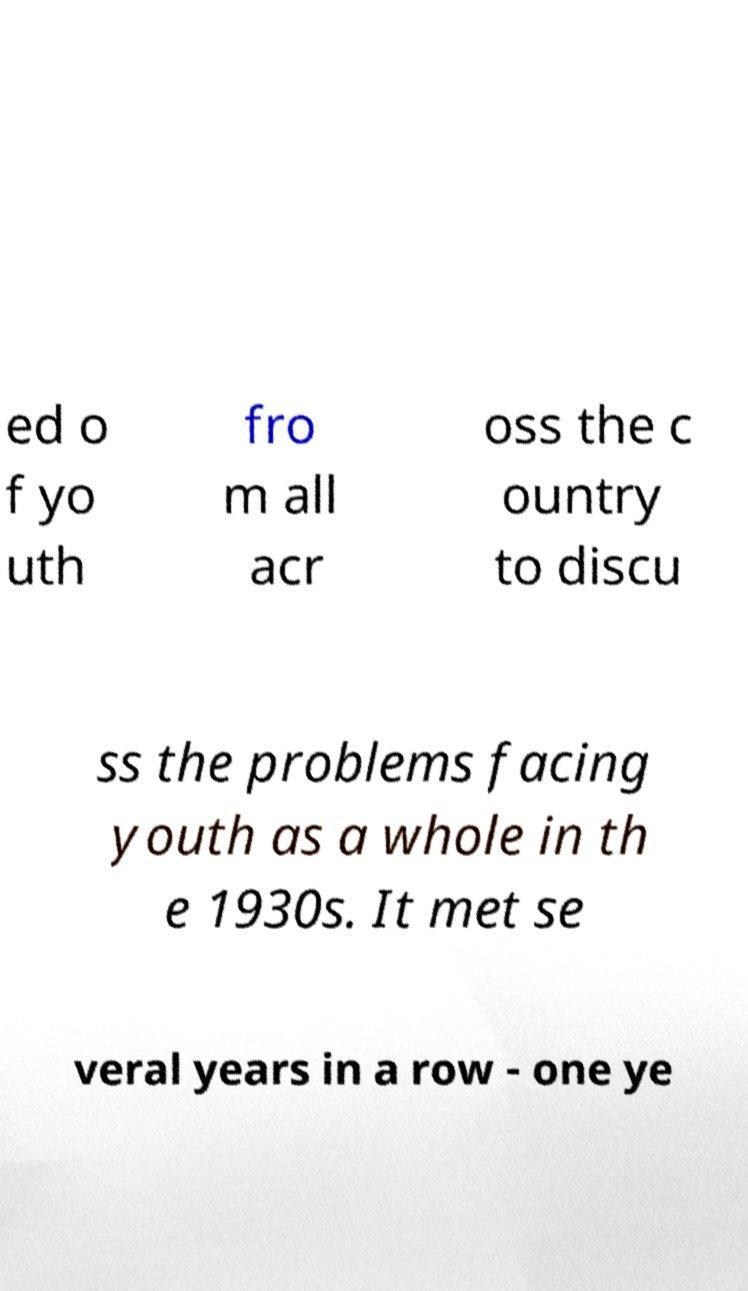Could you extract and type out the text from this image? ed o f yo uth fro m all acr oss the c ountry to discu ss the problems facing youth as a whole in th e 1930s. It met se veral years in a row - one ye 